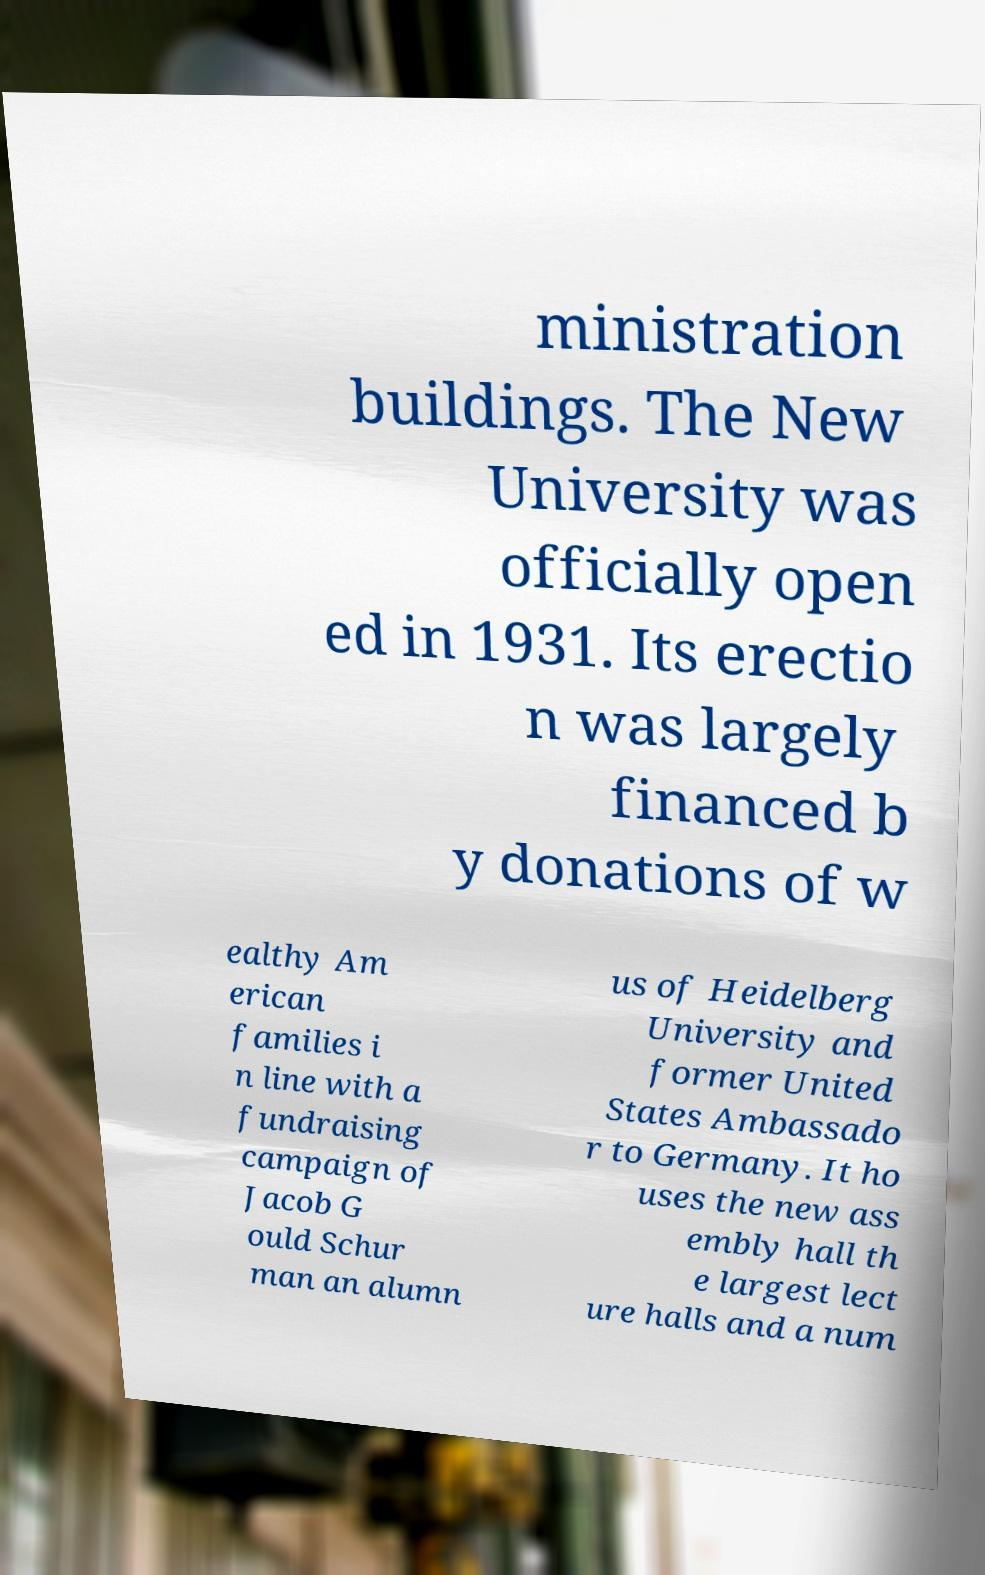There's text embedded in this image that I need extracted. Can you transcribe it verbatim? ministration buildings. The New University was officially open ed in 1931. Its erectio n was largely financed b y donations of w ealthy Am erican families i n line with a fundraising campaign of Jacob G ould Schur man an alumn us of Heidelberg University and former United States Ambassado r to Germany. It ho uses the new ass embly hall th e largest lect ure halls and a num 